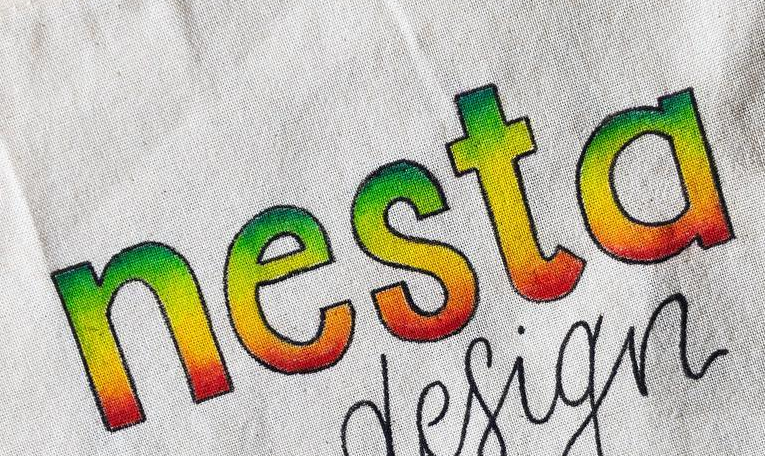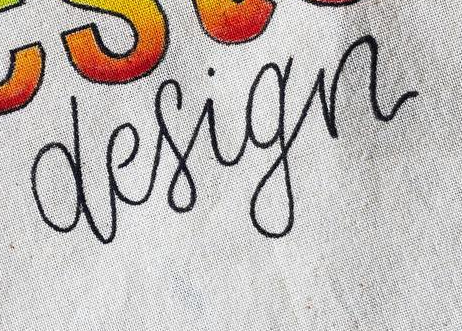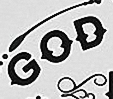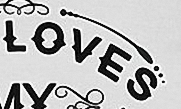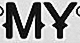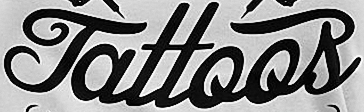What words are shown in these images in order, separated by a semicolon? nesta; design; GOD; LOVES; MY; Tattoos 